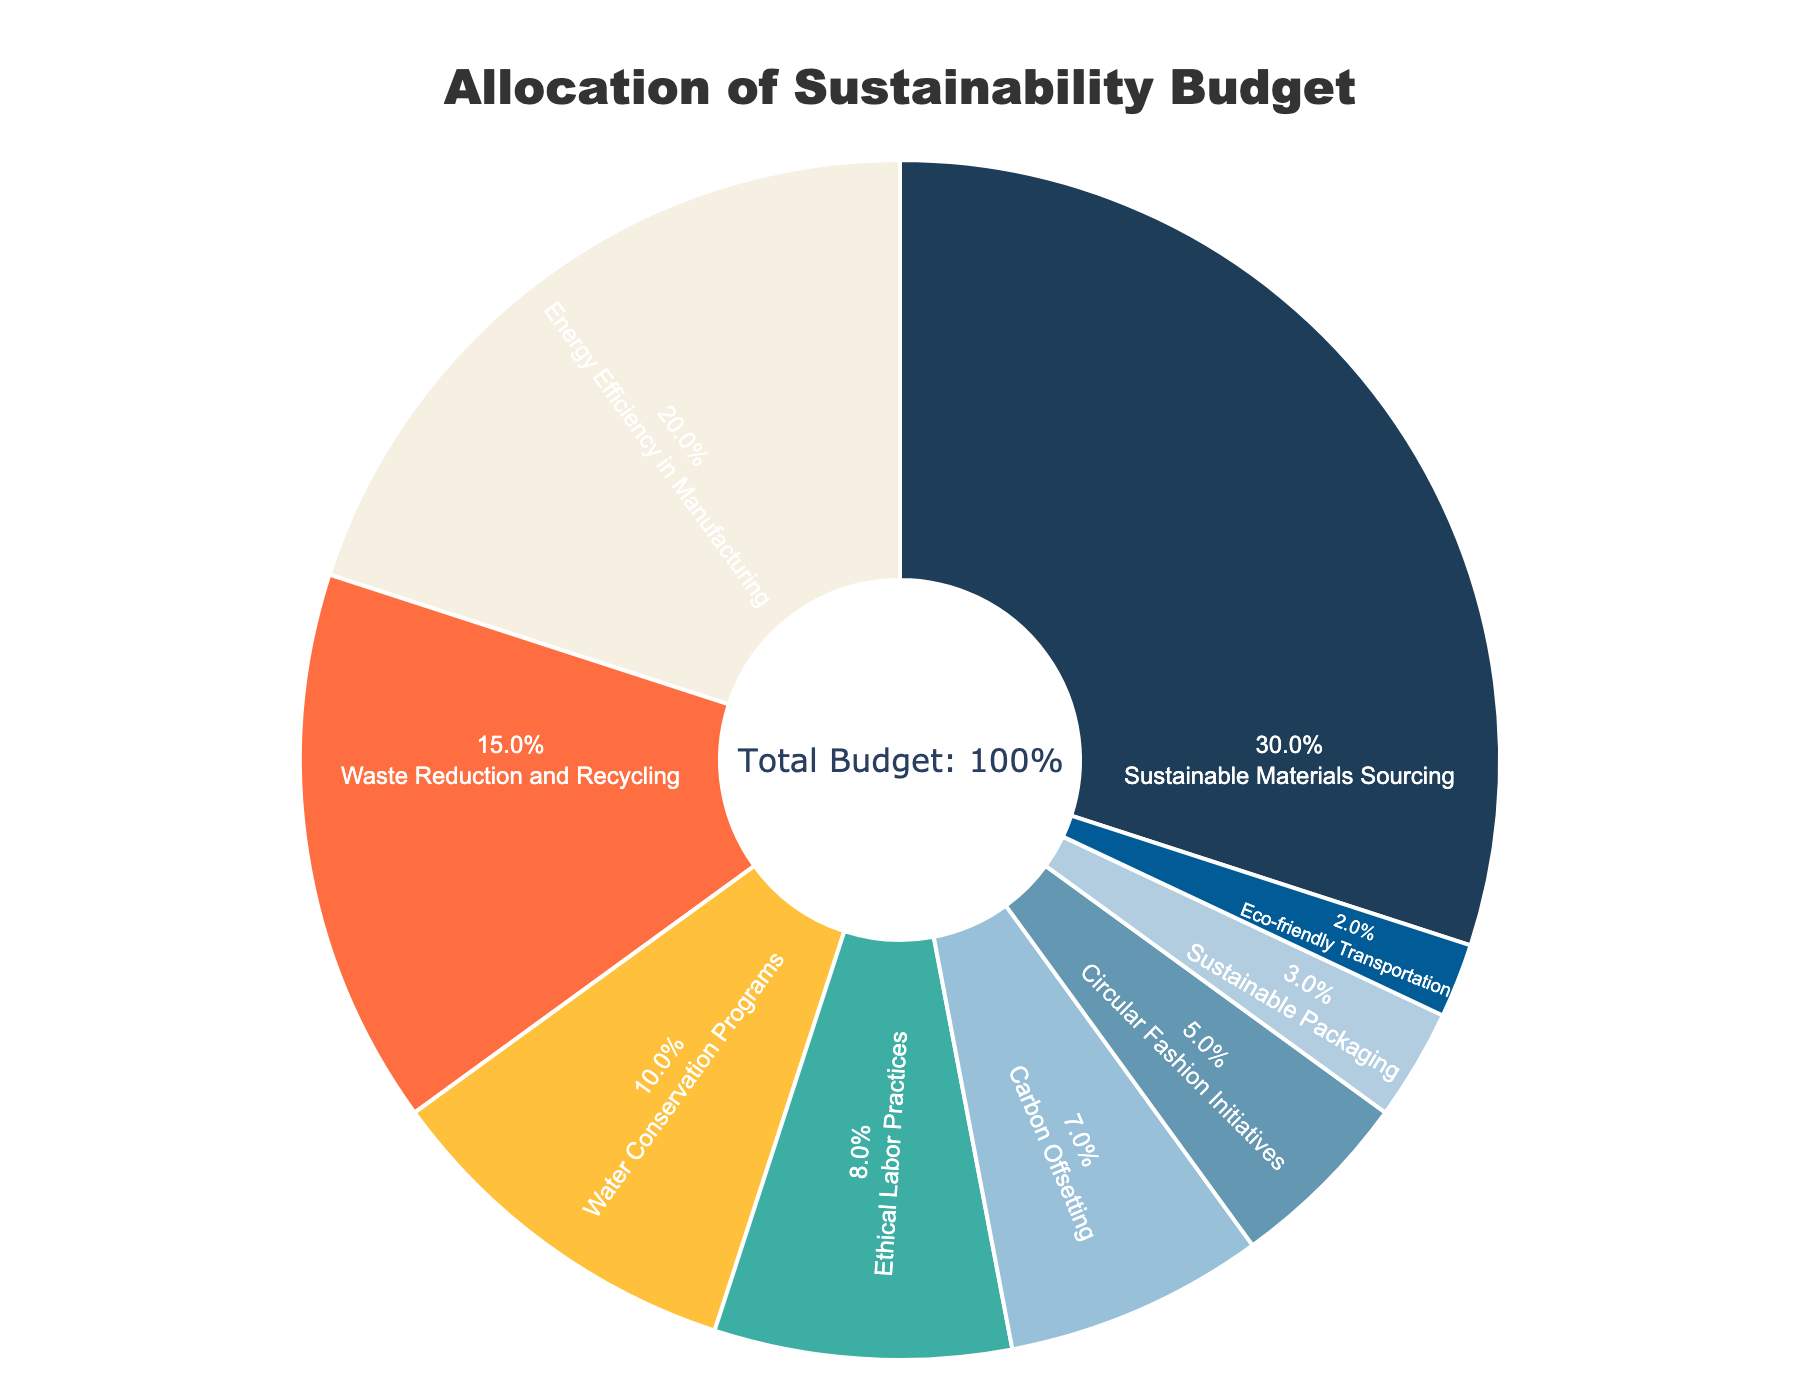What initiative receives the highest budget allocation? By visually inspecting the pie chart, we see that the "Sustainable Materials Sourcing" segment is the largest.
Answer: Sustainable Materials Sourcing Which initiatives have a budget allocation greater than 10%? The segments for "Sustainable Materials Sourcing" (30%), "Energy Efficiency in Manufacturing" (20%), and "Waste Reduction and Recycling" (15%) are all above 10%.
Answer: Sustainable Materials Sourcing, Energy Efficiency in Manufacturing, Waste Reduction and Recycling What is the combined budget allocation for initiatives related to materials and packaging? "Sustainable Materials Sourcing" has 30% and "Sustainable Packaging" has 3%; adding these gives 30% + 3% = 33%.
Answer: 33% Is the budget allocation for "Carbon Offsetting" greater than "Eco-friendly Transportation"? The pie chart shows "Carbon Offsetting" at 7% and "Eco-friendly Transportation" at 2%; 7% is greater than 2%.
Answer: Yes What percentage of the budget is allocated to initiatives focused on waste and recycling? "Waste Reduction and Recycling" has 15% allocation.
Answer: 15% Compare the budget allocations for "Water Conservation Programs" and "Ethical Labor Practices." Which one is higher? "Water Conservation Programs" has 10% of the budget, while "Ethical Labor Practices" has 8%. 10% is greater than 8%.
Answer: Water Conservation Programs How much greater is the budget allocation for "Energy Efficiency in Manufacturing" compared to "Circular Fashion Initiatives"? "Energy Efficiency in Manufacturing" has 20%, and "Circular Fashion Initiatives" has 5%. The difference is 20% - 5% = 15%.
Answer: 15% What is the total budget allocation for initiatives other than "Sustainable Materials Sourcing"? The total budget is 100%, and "Sustainable Materials Sourcing" takes 30%. So, 100% - 30% = 70%.
Answer: 70% Which initiatives have the least budget allocation? The smallest segment corresponds to "Eco-friendly Transportation" at 2%.
Answer: Eco-friendly Transportation 